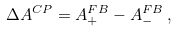Convert formula to latex. <formula><loc_0><loc_0><loc_500><loc_500>\Delta A ^ { C P } = A ^ { F B } _ { + } - A ^ { F B } _ { - } \, ,</formula> 